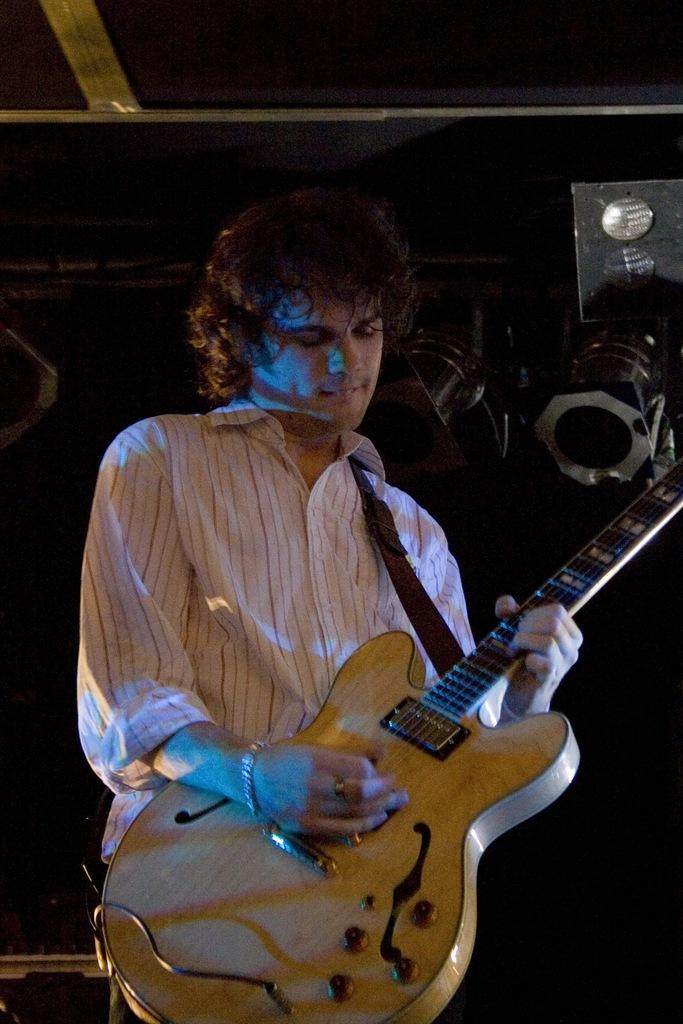Who is present in the image? There is a man in the image. What is the man doing in the image? The man is standing in the image. What object is the man holding in the image? The man is holding a guitar in his hand. What type of truck can be seen in the image? There is no truck present in the image; it features a man holding a guitar. What order is the man giving to the audience in the image? There is no indication of the man giving an order or engaging in a discussion in the image. 